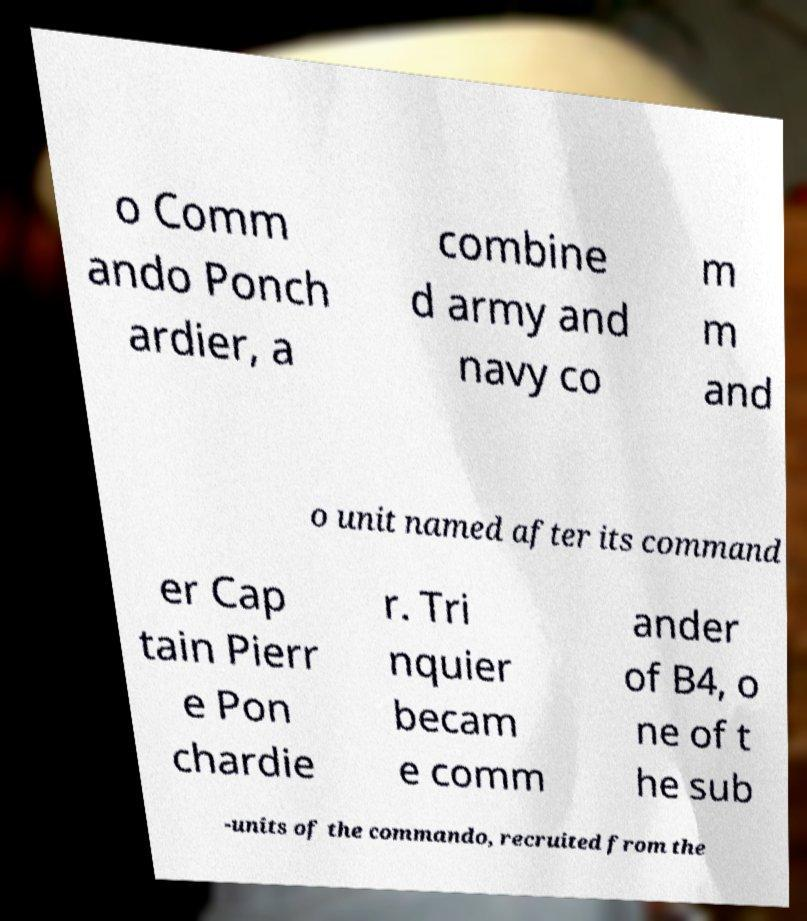Can you accurately transcribe the text from the provided image for me? o Comm ando Ponch ardier, a combine d army and navy co m m and o unit named after its command er Cap tain Pierr e Pon chardie r. Tri nquier becam e comm ander of B4, o ne of t he sub -units of the commando, recruited from the 